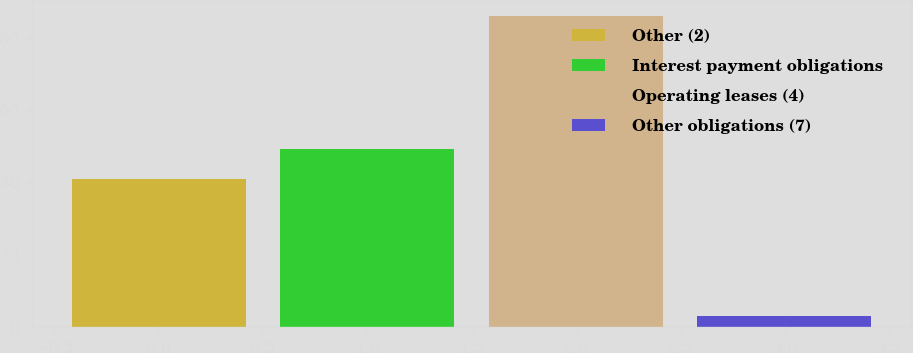<chart> <loc_0><loc_0><loc_500><loc_500><bar_chart><fcel>Other (2)<fcel>Interest payment obligations<fcel>Operating leases (4)<fcel>Other obligations (7)<nl><fcel>41<fcel>49.3<fcel>86<fcel>3<nl></chart> 